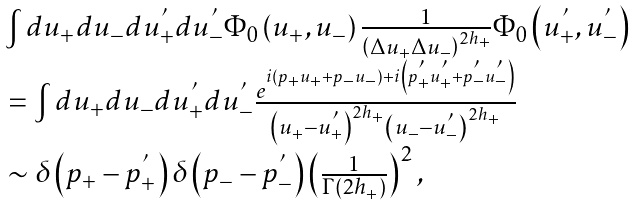Convert formula to latex. <formula><loc_0><loc_0><loc_500><loc_500>\begin{array} { l } \int { d u _ { + } d u _ { - } d u _ { + } ^ { ^ { \prime } } } d u _ { - } ^ { ^ { \prime } } \Phi _ { 0 } \left ( { u _ { + } , u _ { - } } \right ) \frac { 1 } { { \left ( { \Delta u _ { + } \Delta u _ { - } } \right ) ^ { 2 h _ { + } } } } \Phi _ { 0 } \left ( { u _ { + } ^ { ^ { \prime } } , u _ { - } ^ { ^ { \prime } } } \right ) \\ \, = \int { d u _ { + } d u _ { - } d u _ { + } ^ { ^ { \prime } } } d u _ { - } ^ { ^ { \prime } } \frac { { e ^ { i \left ( { p _ { + } u _ { + } + p _ { - } u _ { - } } \right ) + i \left ( { p _ { + } ^ { ^ { \prime } } u _ { + } ^ { ^ { \prime } } + p _ { - } ^ { ^ { \prime } } u _ { - } ^ { ^ { \prime } } } \right ) } } } { { \left ( { u _ { + } - u _ { + } ^ { ^ { \prime } } } \right ) ^ { 2 h _ { + } } \left ( { u _ { - } - u _ { - } ^ { ^ { \prime } } } \right ) ^ { 2 h _ { + } } } } \\ \, \sim \delta \left ( { p _ { + } - p _ { + } ^ { ^ { \prime } } } \right ) \delta \left ( { p _ { - } - p _ { - } ^ { ^ { \prime } } } \right ) \left ( { \frac { 1 } { { \Gamma \left ( { 2 h _ { + } } \right ) } } } \right ) ^ { 2 } , \end{array}</formula> 